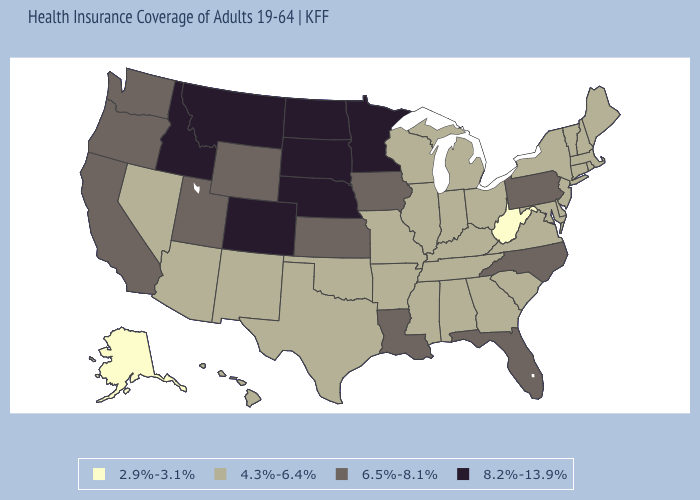Which states have the highest value in the USA?
Keep it brief. Colorado, Idaho, Minnesota, Montana, Nebraska, North Dakota, South Dakota. What is the value of Virginia?
Write a very short answer. 4.3%-6.4%. What is the value of Tennessee?
Answer briefly. 4.3%-6.4%. Name the states that have a value in the range 8.2%-13.9%?
Write a very short answer. Colorado, Idaho, Minnesota, Montana, Nebraska, North Dakota, South Dakota. Which states have the lowest value in the USA?
Short answer required. Alaska, West Virginia. Among the states that border Minnesota , which have the lowest value?
Short answer required. Wisconsin. What is the highest value in the West ?
Keep it brief. 8.2%-13.9%. What is the lowest value in the USA?
Concise answer only. 2.9%-3.1%. Name the states that have a value in the range 6.5%-8.1%?
Write a very short answer. California, Florida, Iowa, Kansas, Louisiana, North Carolina, Oregon, Pennsylvania, Utah, Washington, Wyoming. What is the lowest value in the USA?
Be succinct. 2.9%-3.1%. What is the value of South Carolina?
Concise answer only. 4.3%-6.4%. Does North Carolina have the highest value in the South?
Concise answer only. Yes. Does Mississippi have the lowest value in the USA?
Give a very brief answer. No. What is the lowest value in the USA?
Be succinct. 2.9%-3.1%. Does West Virginia have the lowest value in the USA?
Concise answer only. Yes. 